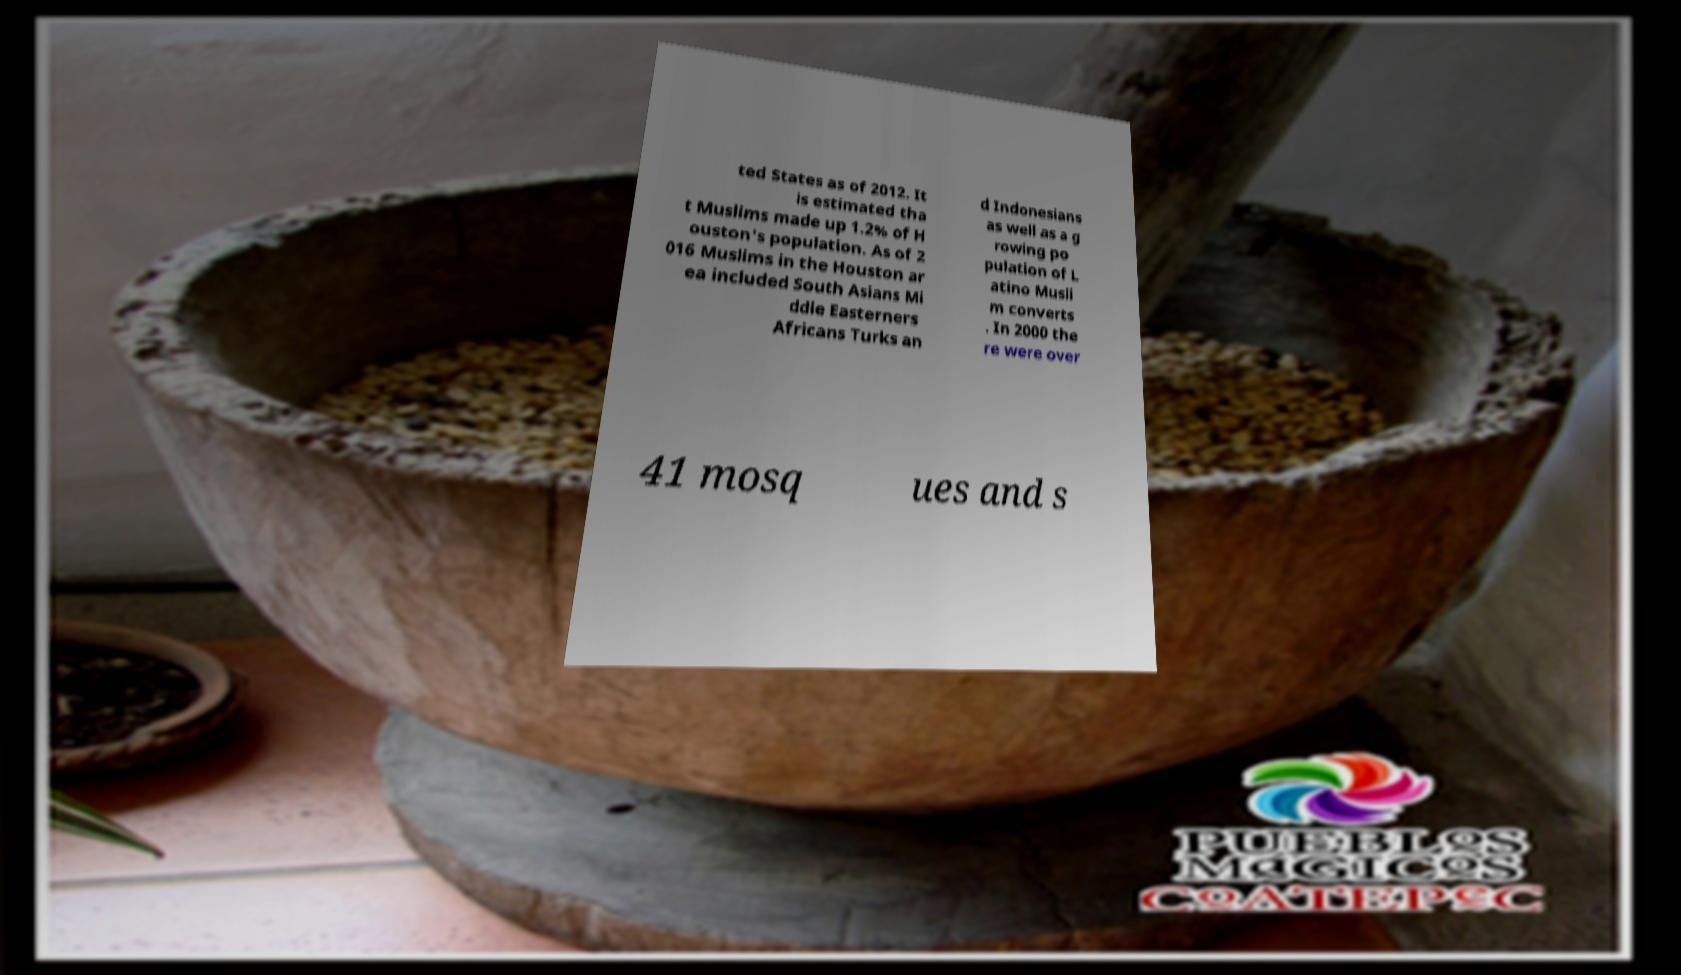For documentation purposes, I need the text within this image transcribed. Could you provide that? ted States as of 2012. It is estimated tha t Muslims made up 1.2% of H ouston's population. As of 2 016 Muslims in the Houston ar ea included South Asians Mi ddle Easterners Africans Turks an d Indonesians as well as a g rowing po pulation of L atino Musli m converts . In 2000 the re were over 41 mosq ues and s 